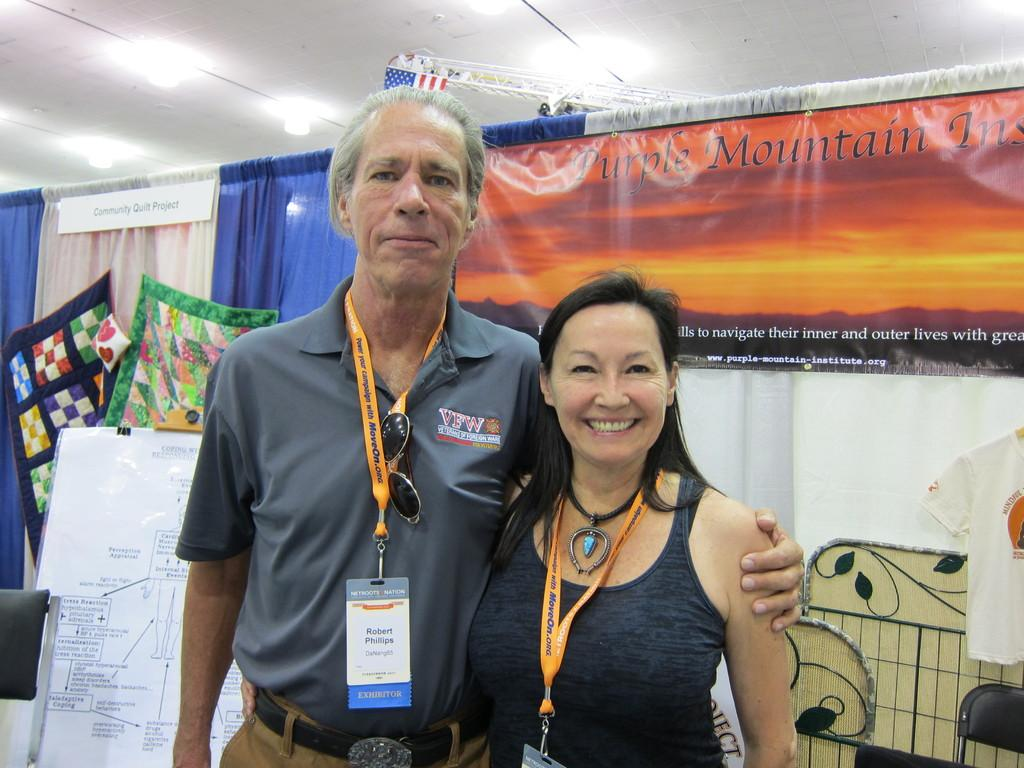Who are the two people in the center of the image? There is a man and a woman standing in the center of the image. What can be seen in the background of the image? There is a board, a wall, clothes, a curtain, a poster, a t-shirt, and a chair in the background of the image. Can you describe the board in the background? Unfortunately, the facts provided do not give any details about the board, so we cannot describe it further. How many fish are swimming in the t-shirt in the background of the image? There are no fish present in the image, let alone swimming in the t-shirt. 